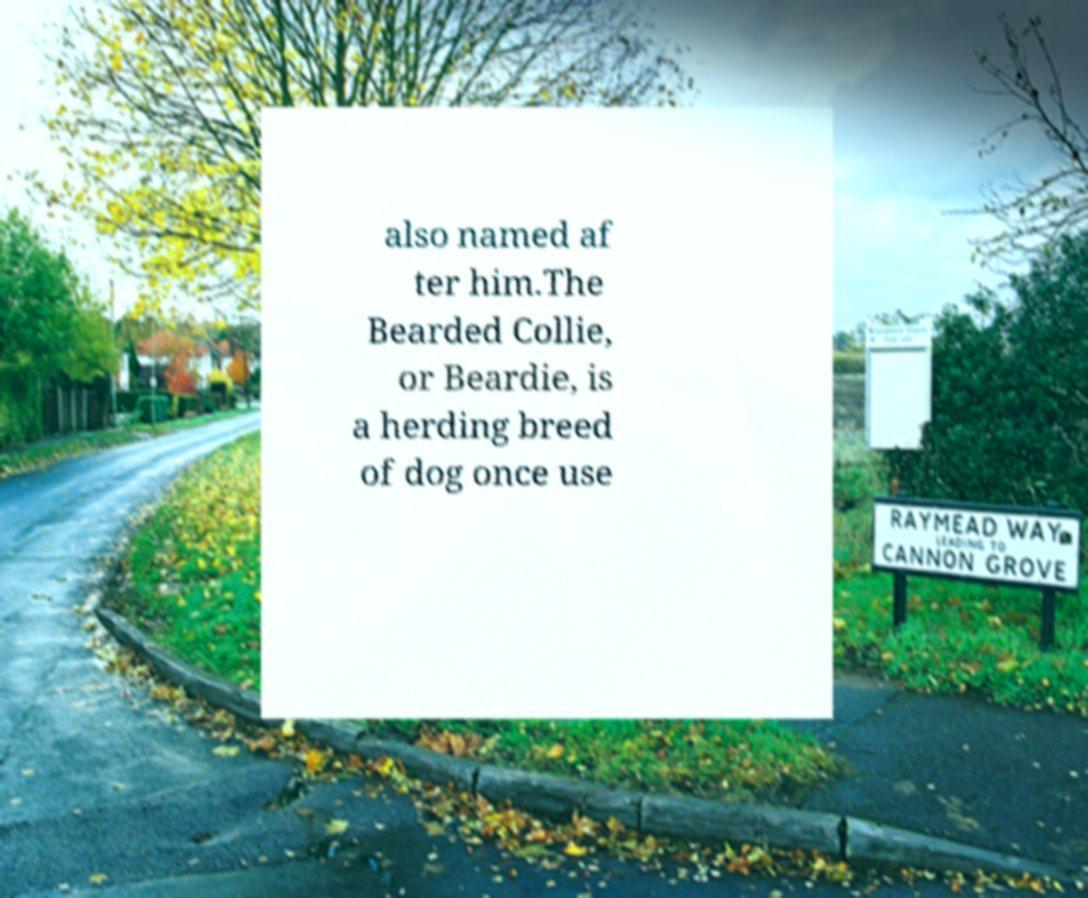Can you accurately transcribe the text from the provided image for me? also named af ter him.The Bearded Collie, or Beardie, is a herding breed of dog once use 